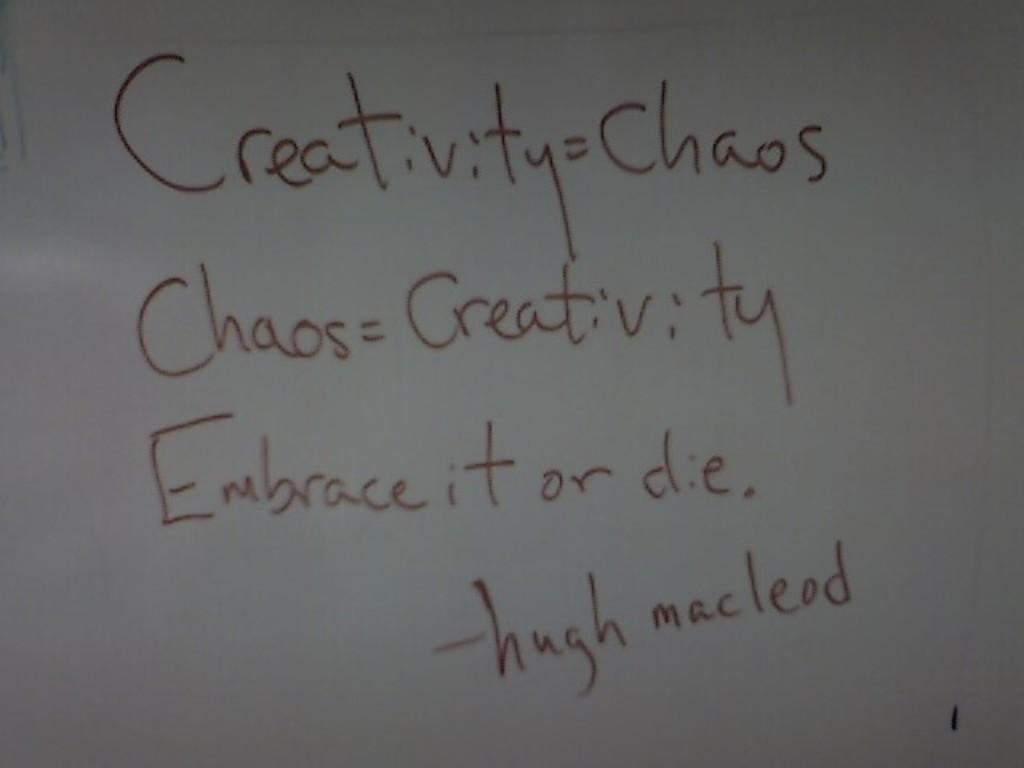<image>
Create a compact narrative representing the image presented. The writing on the board relates to creativity being equal to chaos. 